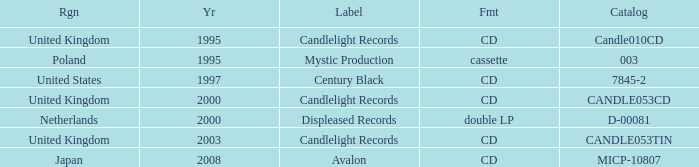Parse the full table. {'header': ['Rgn', 'Yr', 'Label', 'Fmt', 'Catalog'], 'rows': [['United Kingdom', '1995', 'Candlelight Records', 'CD', 'Candle010CD'], ['Poland', '1995', 'Mystic Production', 'cassette', '003'], ['United States', '1997', 'Century Black', 'CD', '7845-2'], ['United Kingdom', '2000', 'Candlelight Records', 'CD', 'CANDLE053CD'], ['Netherlands', '2000', 'Displeased Records', 'double LP', 'D-00081'], ['United Kingdom', '2003', 'Candlelight Records', 'CD', 'CANDLE053TIN'], ['Japan', '2008', 'Avalon', 'CD', 'MICP-10807']]} In which format does candlelight records operate? CD, CD, CD. 